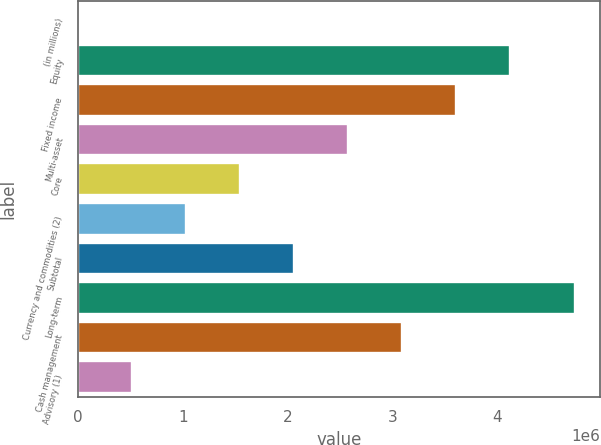Convert chart to OTSL. <chart><loc_0><loc_0><loc_500><loc_500><bar_chart><fcel>(in millions)<fcel>Equity<fcel>Fixed income<fcel>Multi-asset<fcel>Core<fcel>Currency and commodities (2)<fcel>Subtotal<fcel>Long-term<fcel>Cash management<fcel>Advisory (1)<nl><fcel>2016<fcel>4.11868e+06<fcel>3.6041e+06<fcel>2.57493e+06<fcel>1.54577e+06<fcel>1.03118e+06<fcel>2.06035e+06<fcel>4.74149e+06<fcel>3.08952e+06<fcel>516600<nl></chart> 